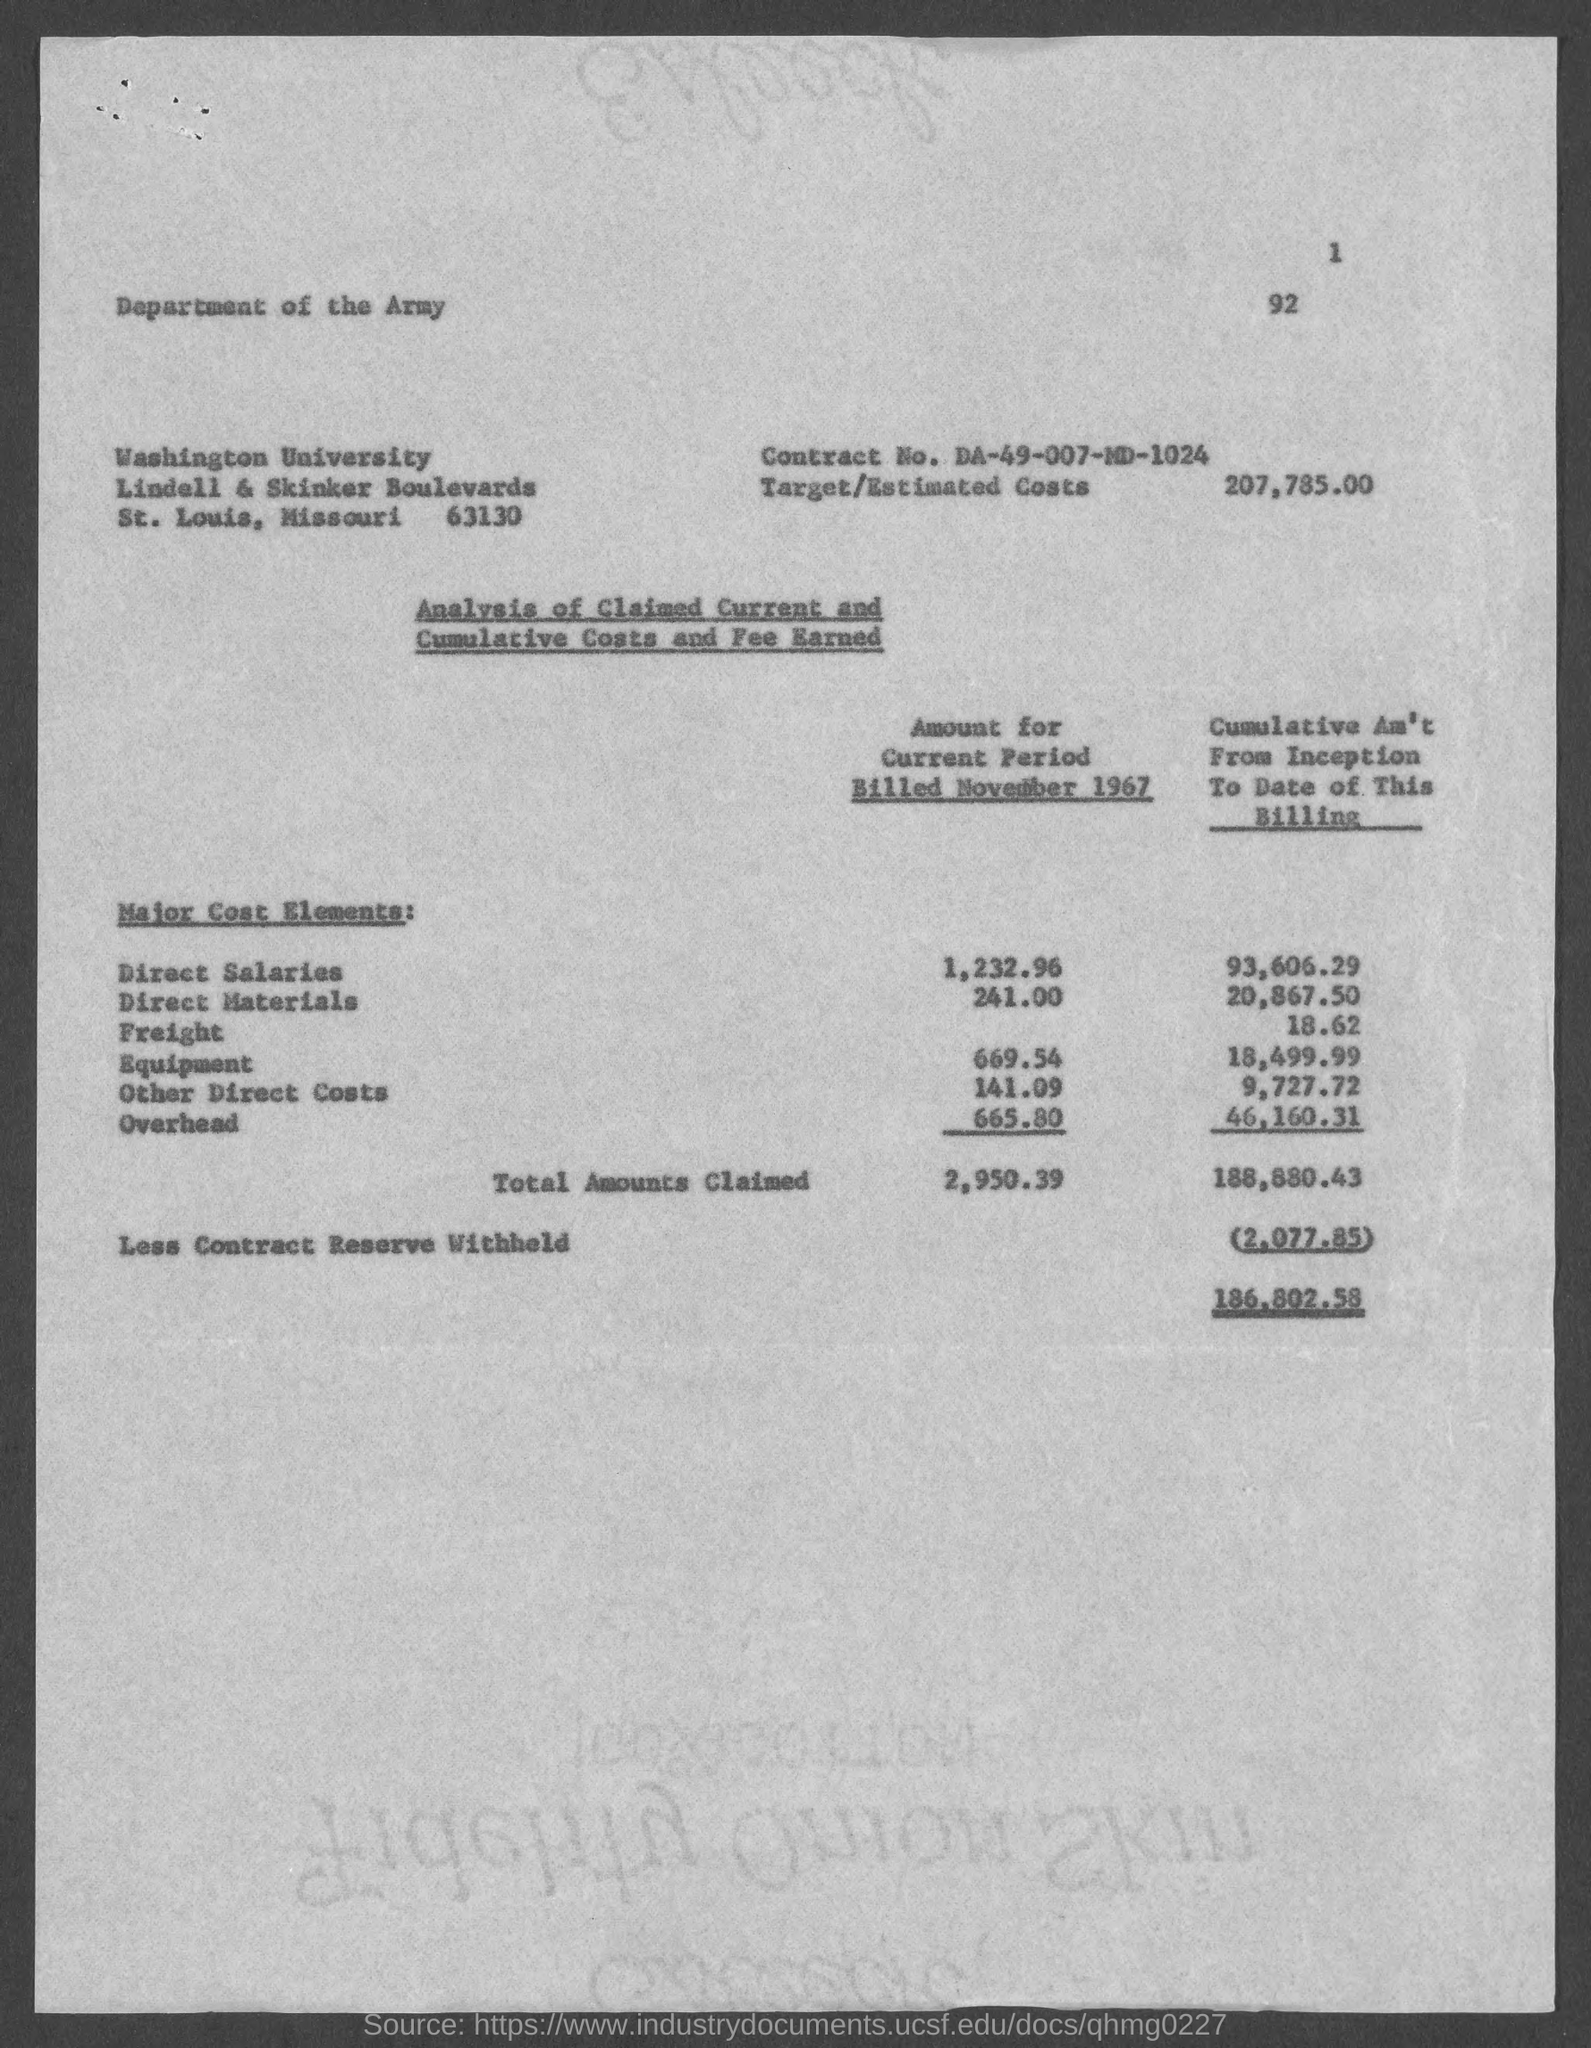In which state is washington university at?
Keep it short and to the point. Missouri. What is the contract no.?
Your answer should be very brief. DA-49-007-MD-1024. What is the target/estimated costs ?
Your answer should be compact. 207,785.00. What is the amount for current period billed november 1967 of direct salaries ?
Provide a succinct answer. 1,232.96. What is the amount for current period billed november 1967 of direct materials ?
Your response must be concise. 241.00. What is the amount for current period billed november 1967 of equipment ?
Give a very brief answer. 669.54. What is the amount for current period billed november 1967 of other direct costs?
Offer a terse response. 141.09. What is the amount for current period billed november 1967 of overhead?
Give a very brief answer. 665.80. What is the less contract reserve withheld ?
Provide a succinct answer. (2,077.85). 